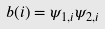Convert formula to latex. <formula><loc_0><loc_0><loc_500><loc_500>b ( i ) = \psi _ { 1 , i } \psi _ { 2 , i }</formula> 